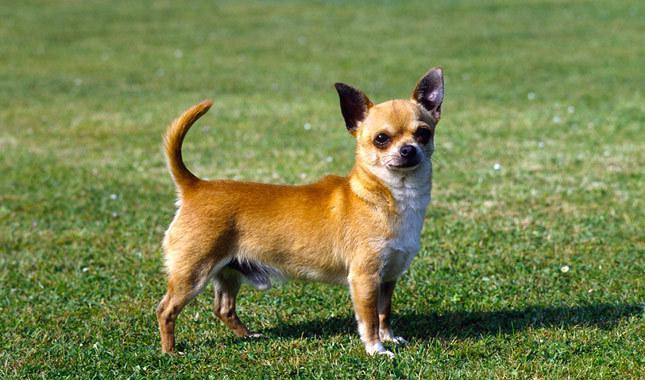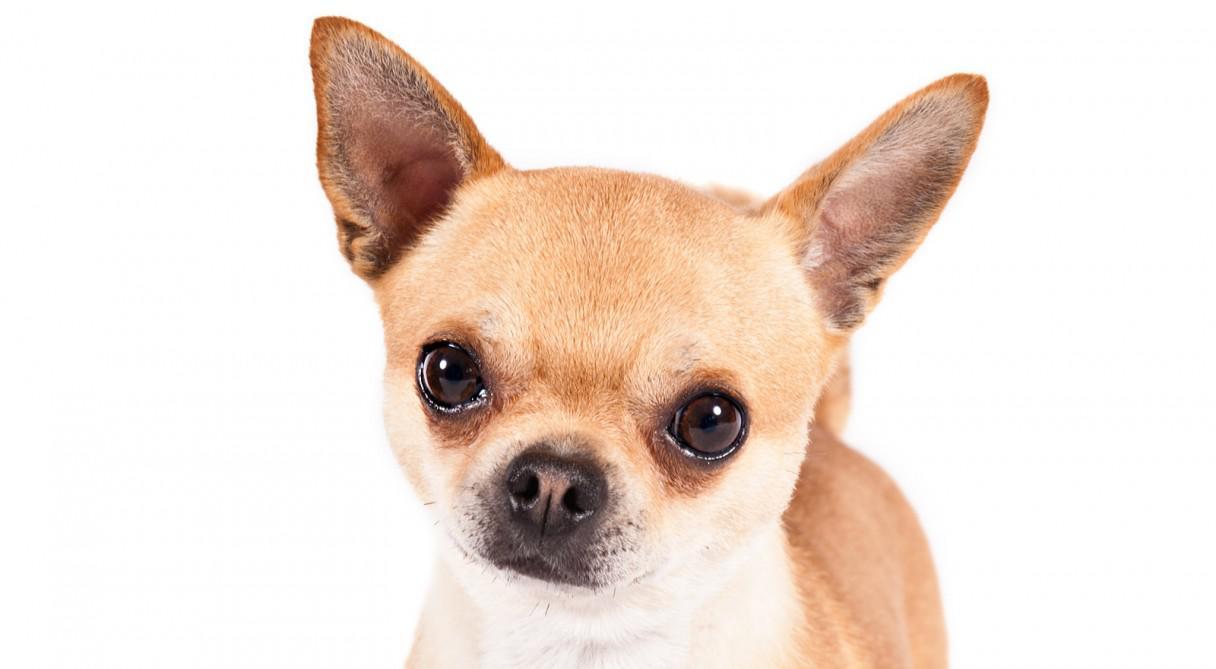The first image is the image on the left, the second image is the image on the right. Analyze the images presented: Is the assertion "There are two chihuahuas." valid? Answer yes or no. Yes. The first image is the image on the left, the second image is the image on the right. Evaluate the accuracy of this statement regarding the images: "Each image contains exactly one small dog.". Is it true? Answer yes or no. Yes. 